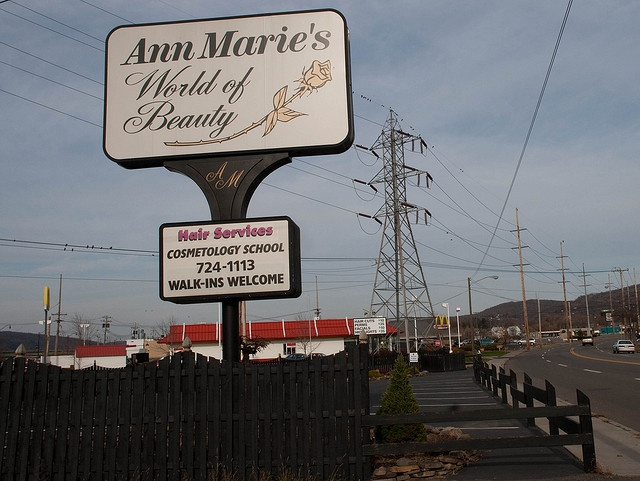Describe the objects in this image and their specific colors. I can see car in gray, black, and darkgray tones, car in gray, black, maroon, and tan tones, and car in gray, black, darkgray, and lightgray tones in this image. 